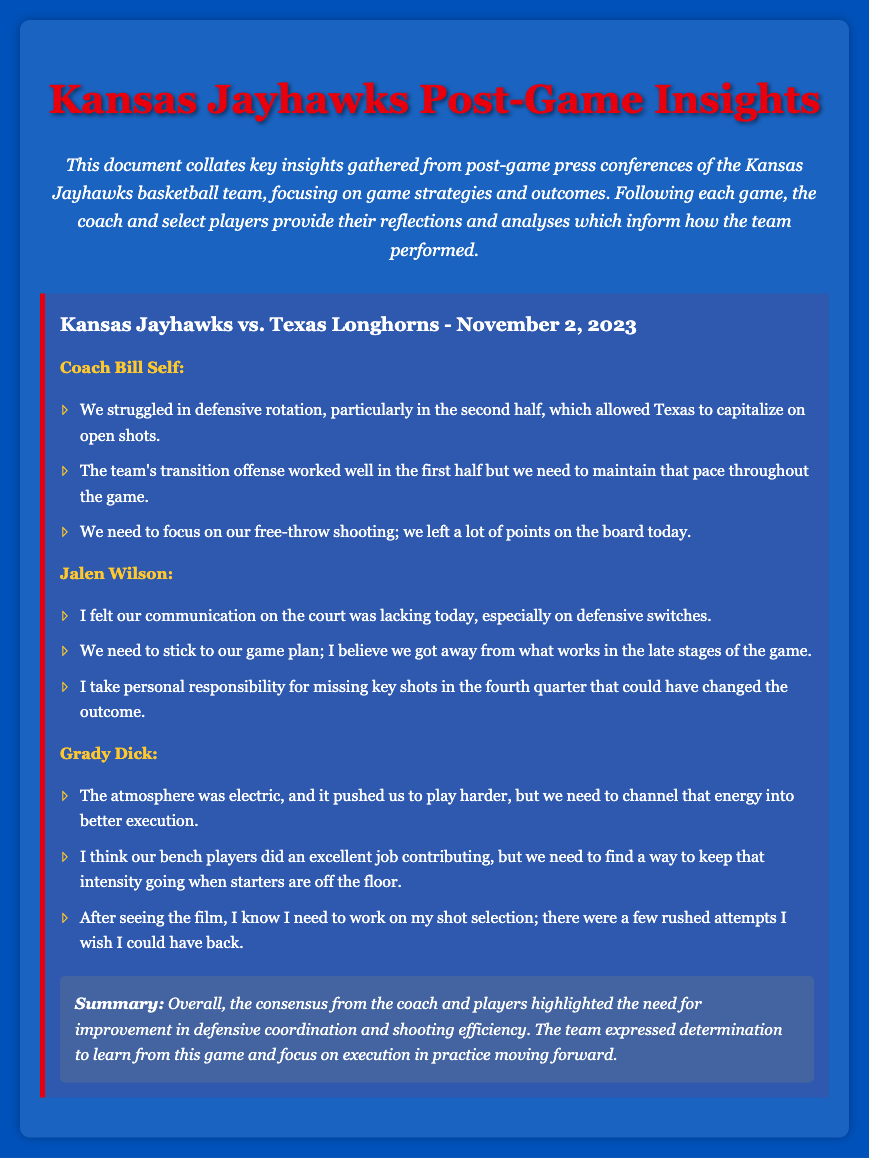What is the date of the game? The date of the game is prominently stated in the game section, describing the match between Kansas Jayhawks and Texas Longhorns as occurring on November 2, 2023.
Answer: November 2, 2023 Who is the coach mentioned in the document? The coach named in the press conference transcript is introduced at the beginning of his speaking section, identified as Coach Bill Self.
Answer: Coach Bill Self What was highlighted as a key issue by Coach Bill Self? The document lists specific insights from Coach Bill Self, with one key issue being mentioned about the team's defensive rotation struggles.
Answer: Defensive rotation Which player expressed personal responsibility for missing key shots? In the players' part of the transcript, Jalen Wilson openly states taking personal responsibility for his performance, particularly regarding missed shots.
Answer: Jalen Wilson What did Grady Dick mention about the bench players? Grady Dick noted the positive contributions made by the bench players during the game while also highlighting a need for consistent intensity.
Answer: Excellent job contributing What aspect of shooting did the team need to focus on, according to Coach Self? In his remarks, Coach Self specifically called out a focus on free-throw shooting as an area where the team could improve its scoring efficiency.
Answer: Free-throw shooting What did Jalen Wilson suggest was lacking? Jalen Wilson pointed out deficiency in communication on the court, particularly regarding defensive switches, indicating a collaborative issue.
Answer: Communication What was the overall sentiment expressed in the summary? The summary included an overall sentiment that emphasized the team's determination to improve and focus on execution in future practices.
Answer: Determination to improve 